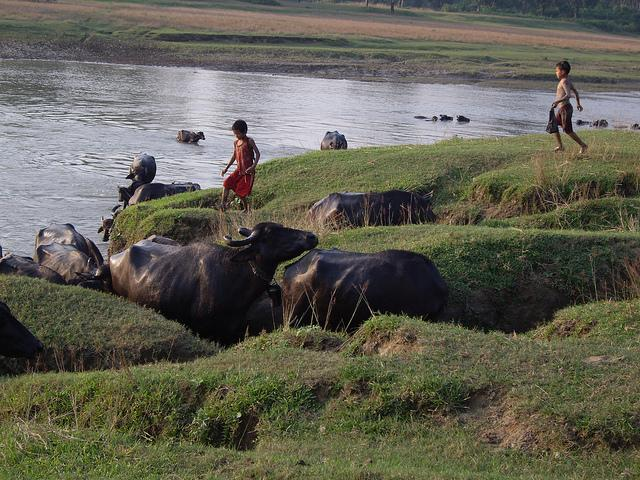How many children are running onto the cape with the water cows?

Choices:
A) five
B) four
C) three
D) two two 